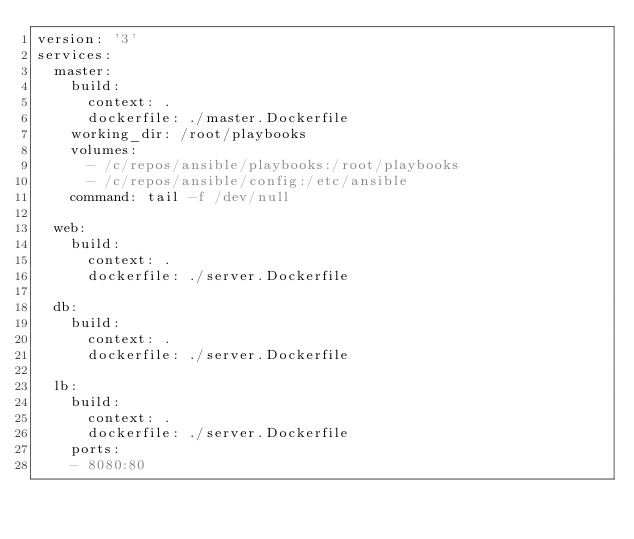Convert code to text. <code><loc_0><loc_0><loc_500><loc_500><_YAML_>version: '3'
services:
  master:
    build:
      context: .
      dockerfile: ./master.Dockerfile
    working_dir: /root/playbooks
    volumes:
      - /c/repos/ansible/playbooks:/root/playbooks
      - /c/repos/ansible/config:/etc/ansible
    command: tail -f /dev/null
    
  web:
    build:
      context: .
      dockerfile: ./server.Dockerfile

  db:
    build:
      context: .
      dockerfile: ./server.Dockerfile

  lb:
    build:
      context: .
      dockerfile: ./server.Dockerfile
    ports: 
    - 8080:80
</code> 